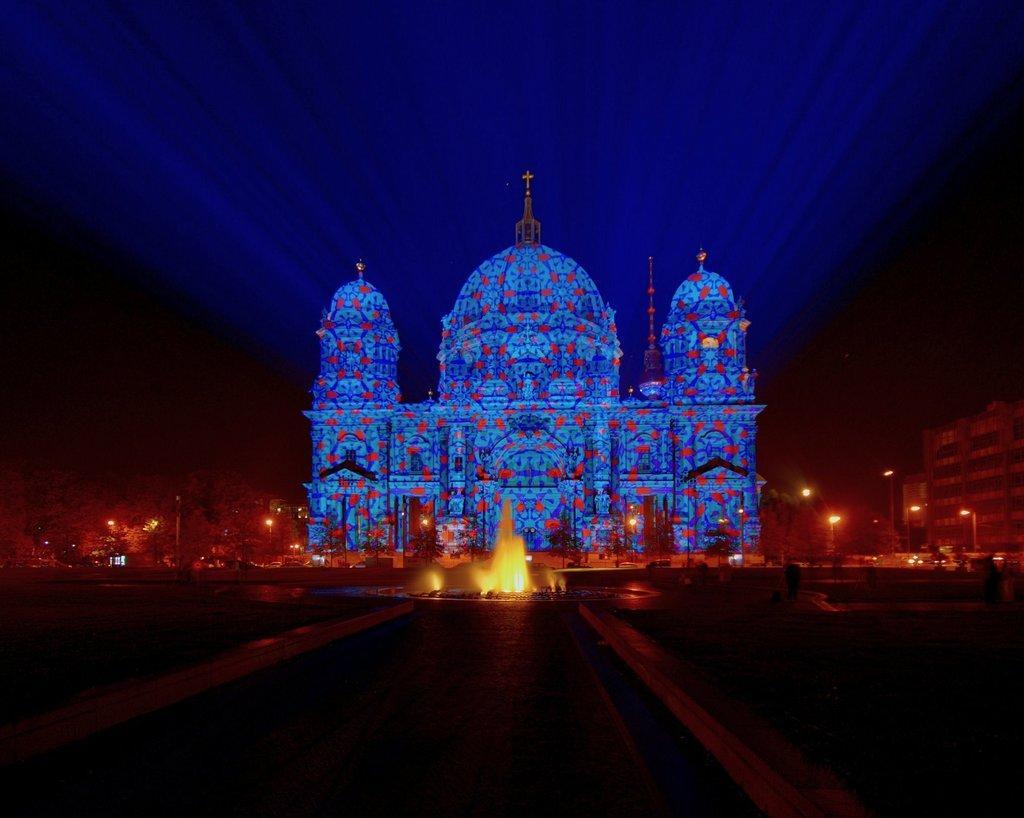Can you describe this image briefly? This image is taken in dark where we can see the fountain, castle construction with lighting, light poles, trees, buildings and the dark sky in the background. 